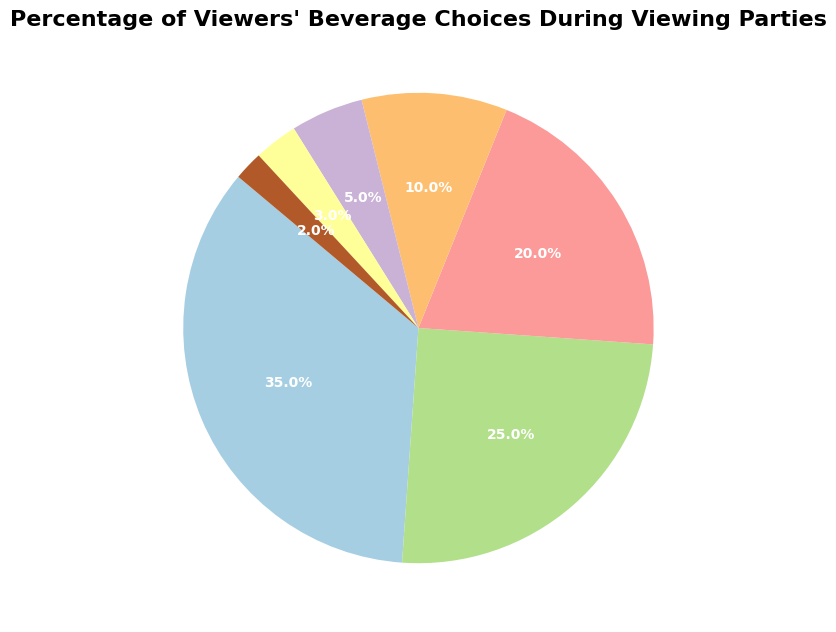What is the most popular beverage among viewers? By looking at the pie chart, we can see that the largest segment represents Beer. The percentage for Beer is the highest.
Answer: Beer Which beverage is consumed by fewer viewers: Juice or Energy Drinks? By comparing the slices of the pie chart, Juice has a smaller segment (3%) compared to Energy Drinks (5%).
Answer: Juice What is the total percentage of viewers choosing non-alcoholic beverages (Soda, Water, Energy Drinks, Juice, Other)? Adding the percentages for Soda (25%), Water (20%), Energy Drinks (5%), Juice (3%), and Other (2%) provides the total percentage: 25 + 20 + 5 + 3 + 2 = 55%.
Answer: 55% Are there more viewers choosing Cocktails or Water? The segment for Water (20%) is larger than the segment for Cocktails (10%) on the pie chart.
Answer: Water Which two beverage choices combined make up exactly half of the total percentage of viewers? Adding Beer (35%) and Soda (25%) equals 60%, but Water (20%) and Cocktails (10%) add up to 30%. However, Beer (35%) and Water (20%) combine to 55%. Look for exact halves, no match perfectly. Instead, consider closest popular matches that sum: Beer and Soda = 35% + 25%.
Answer: None exactly, but Beer (35%) and Soda (25%) = 60% come closest How many times more viewers choose Beer over Juice? By comparing the percentages, Beer (35%) is (35/3) ≈ 11.67 times more commonly chosen than Juice (3%).
Answer: 11.67 times If the percentage of viewers who prefer "Other" beverages were doubled, what would the new pie segment percentage be for "Other"? The current percentage for "Other" is 2%. Doubling this would give us 2 * 2 = 4%.
Answer: 4% Which beverage has the smallest segment in the pie chart? The slice representing "Other" is visibly the smallest with 2%.
Answer: Other Is the number of viewers who prefer Soda greater than the number who prefer Water? Comparing the slices of Soda (25%) and Water (20%), Soda has a larger segment.
Answer: Soda What percent more viewers enjoy Beer compared to Cocktails? Subtracting the percentage of viewers of Cocktails (10%) from that of Beer (35%), we get 35 - 10 = 25%.
Answer: 25% 